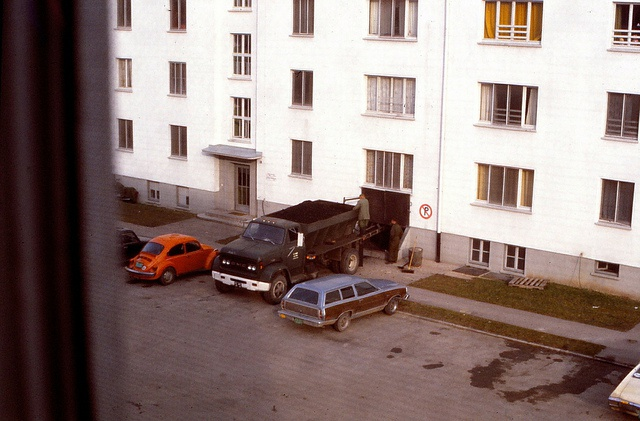Describe the objects in this image and their specific colors. I can see truck in black, maroon, gray, and purple tones, car in black, maroon, and gray tones, car in black, maroon, and red tones, car in black, lightgray, tan, and maroon tones, and car in black and gray tones in this image. 